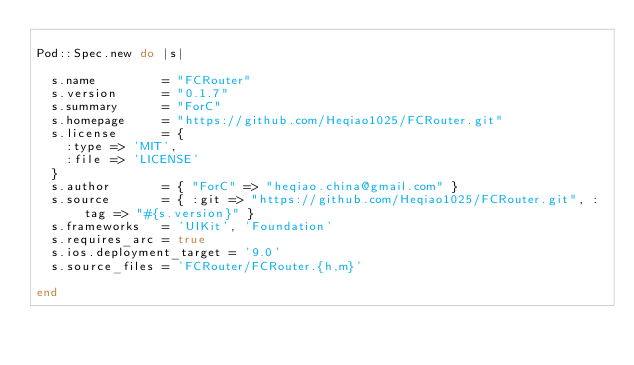<code> <loc_0><loc_0><loc_500><loc_500><_Ruby_>
Pod::Spec.new do |s|

  s.name         = "FCRouter"
  s.version      = "0.1.7"
  s.summary      = "ForC"
  s.homepage     = "https://github.com/Heqiao1025/FCRouter.git"
  s.license      = {
    :type => 'MIT',
    :file => 'LICENSE'
  }
  s.author       = { "ForC" => "heqiao.china@gmail.com" }
  s.source       = { :git => "https://github.com/Heqiao1025/FCRouter.git", :tag => "#{s.version}" }
  s.frameworks   = 'UIKit', 'Foundation'
  s.requires_arc = true
  s.ios.deployment_target = '9.0'
  s.source_files = 'FCRouter/FCRouter.{h,m}'
  
end
</code> 